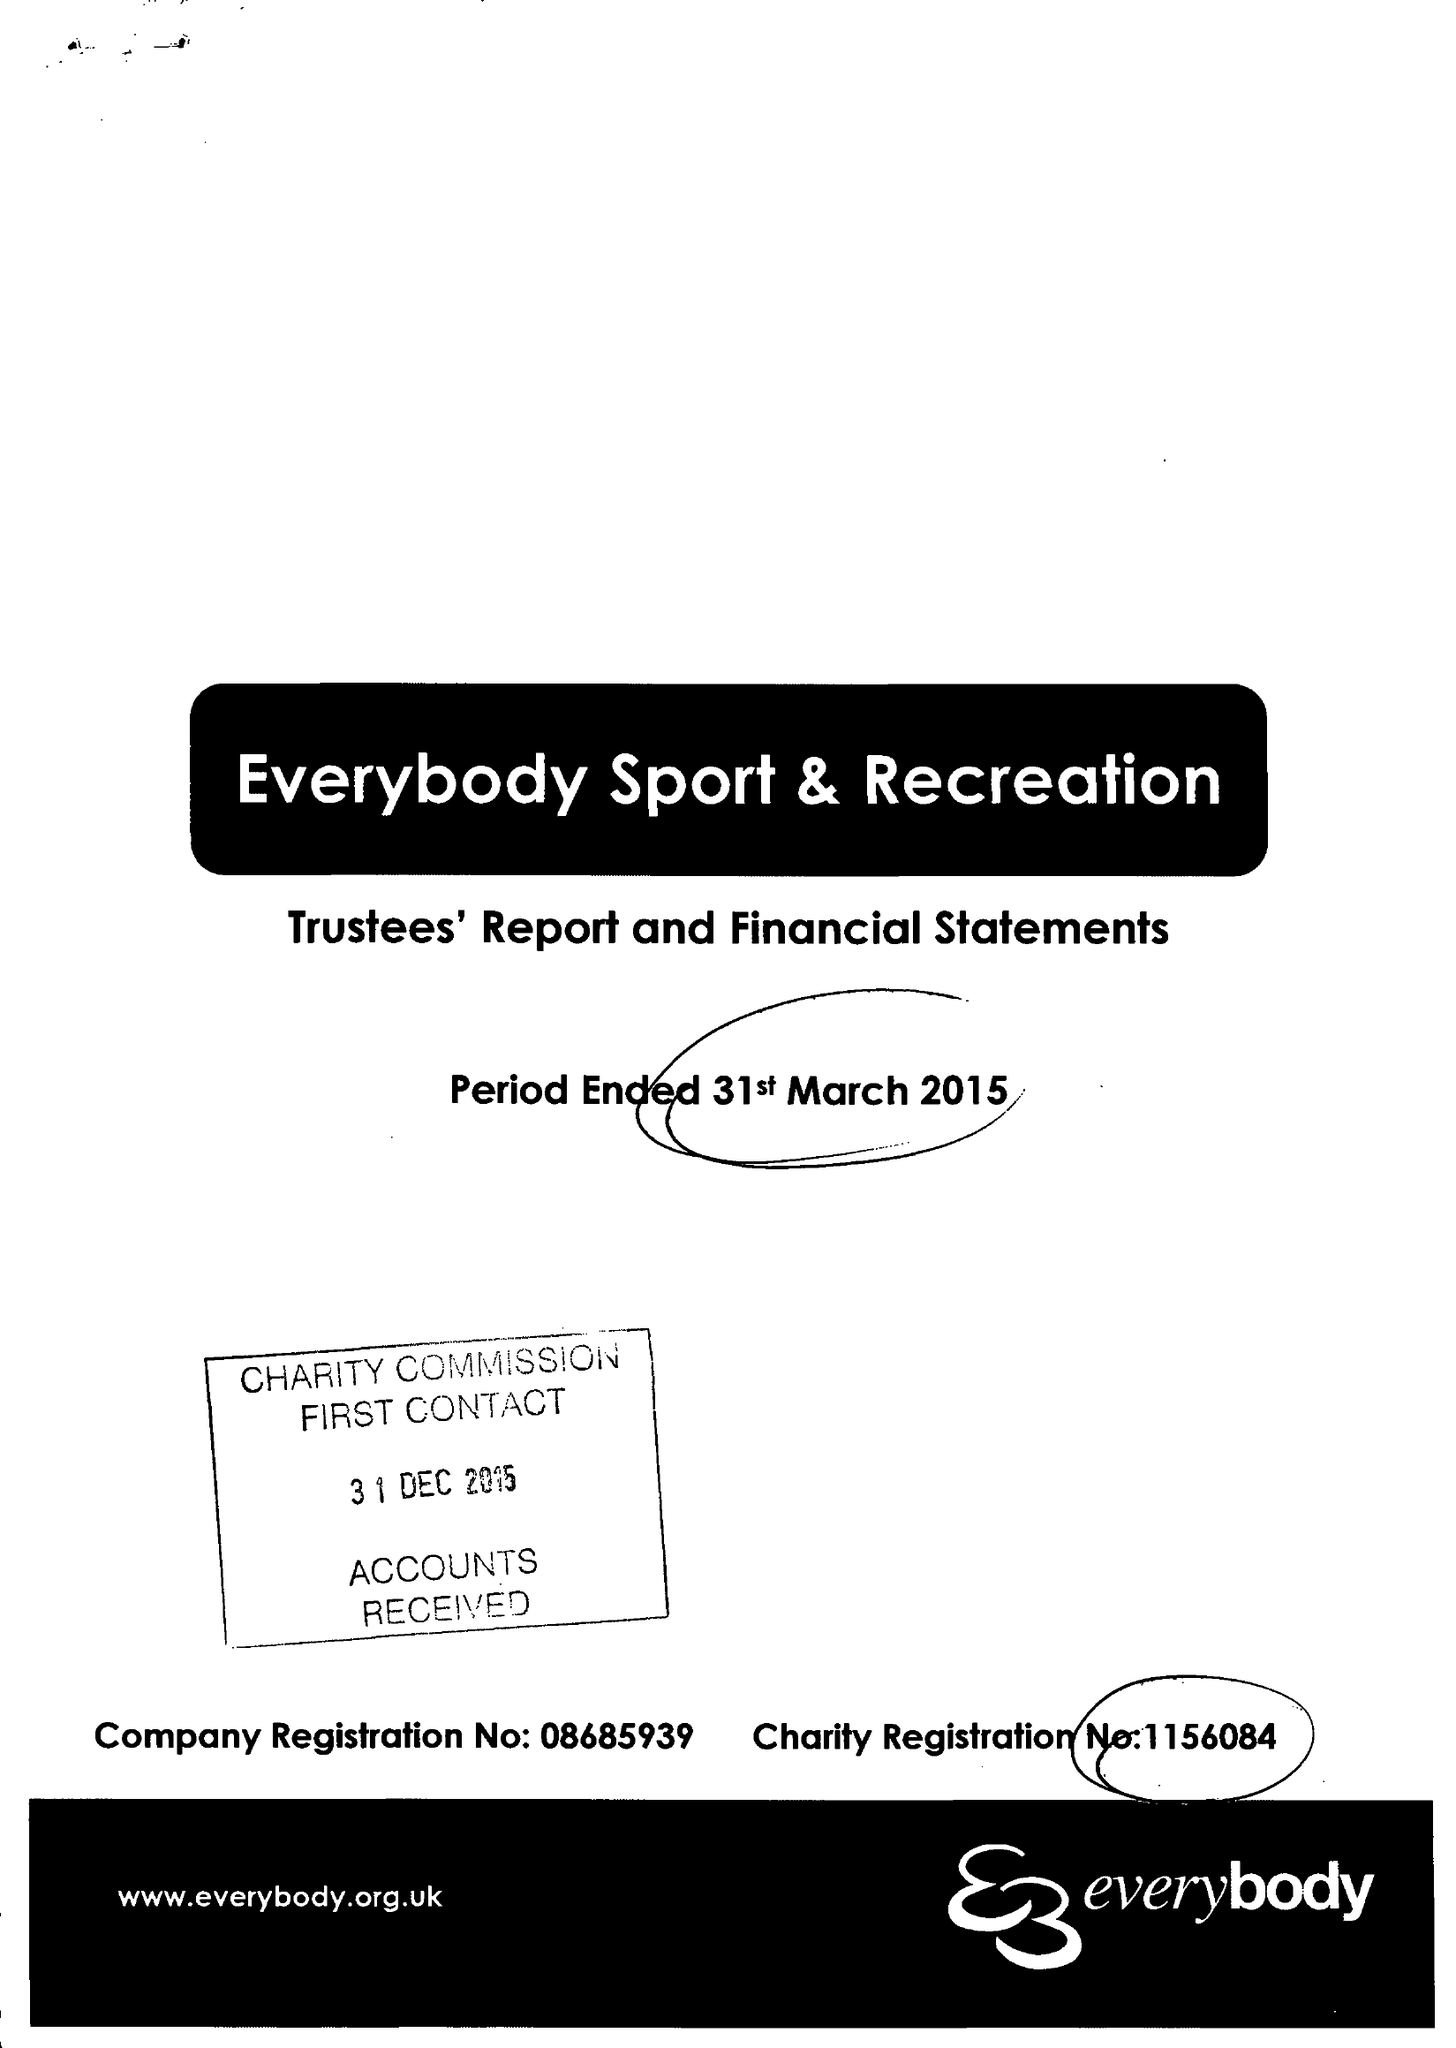What is the value for the income_annually_in_british_pounds?
Answer the question using a single word or phrase. 12630995.00 